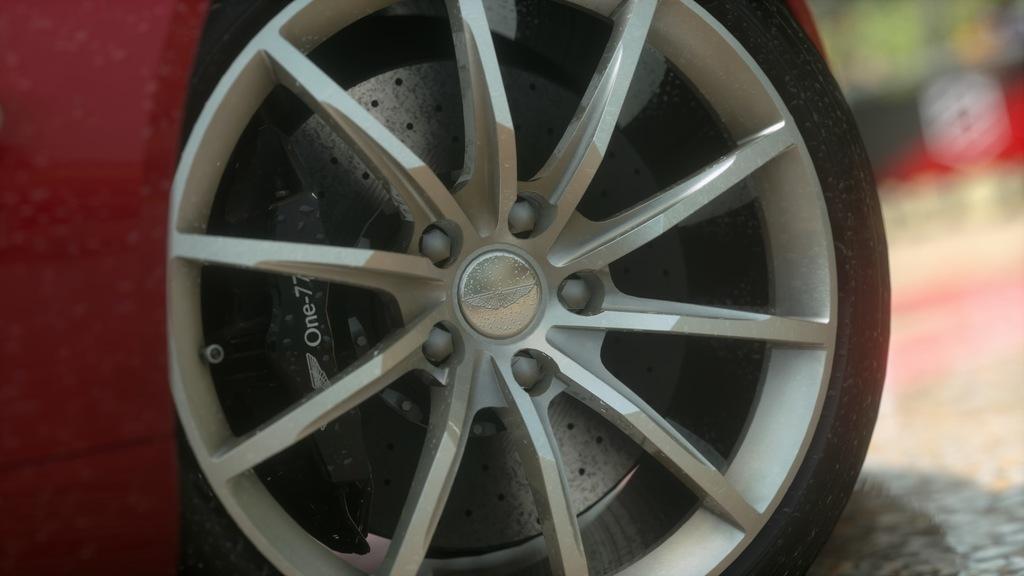Can you describe this image briefly? In this image, I can see a wheel of a vehicle. This is a tire. These are the spokes, which are attached to the center hub. The background looks blurry. 